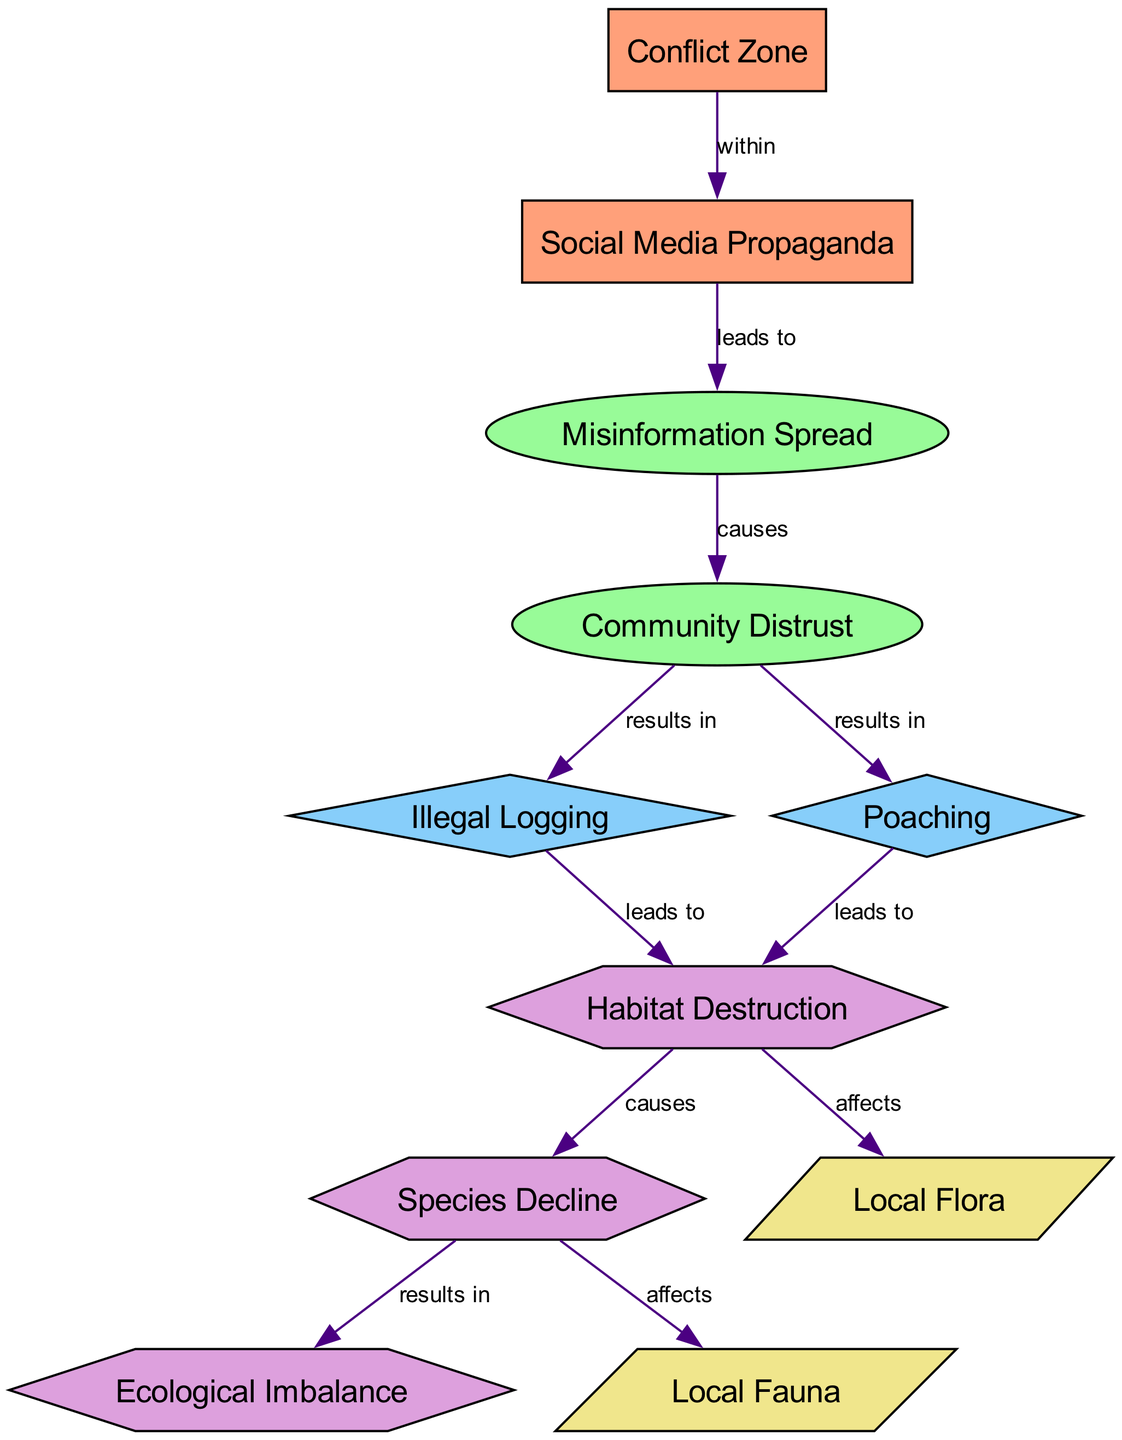What is the total number of nodes in the diagram? The diagram includes 11 different nodes, which are each represented clearly. By counting each node listed, we arrive at the total of 11 nodes.
Answer: 11 How many edges are present in the diagram? The diagram contains 10 edges that connect the various nodes. By examining the edges listed, we can count each connection to find that there are 10 edges.
Answer: 10 What process is caused by misinformation spread? The diagram indicates that misinformation spread causes community distrust as it shows a directed edge from misinformation spread to community distrust.
Answer: Community Distrust What activity results from community distrust? According to the diagram, community distrust results in both illegal logging and poaching, which are connected through directed edges from community distrust.
Answer: Illegal Logging and Poaching Which consequence is directly affected by both habitat destruction and species decline? The diagram shows that both habitat destruction and species decline lead to ecological imbalance as indicated by the edges from these nodes to ecological imbalance.
Answer: Ecological Imbalance What leads to habitat destruction in the context of this diagram? The diagram specifies that both illegal logging and poaching lead to habitat destruction, as indicated by the directed edges from those activities to habitat destruction.
Answer: Illegal Logging and Poaching What is the relationship between social media propaganda and misinformation spread? The diagram denotes that social media propaganda leads to misinformation spread, which is illustrated through a directed edge from social media propaganda to misinformation spread.
Answer: Leads to How do species decline affect local fauna? The diagram states that species decline affects local fauna, as indicated by a directed edge from species decline to local fauna. This signifies a direct impact of species decline on local fauna.
Answer: Affects In which type of environment does social media propaganda occur according to the diagram? The diagram identifies that social media propaganda occurs within a conflict zone, as shown by the directed edge from conflict zone to social media propaganda.
Answer: Conflict Zone What entity is affected by habitat destruction? The diagram shows that local flora is affected by habitat destruction, which is indicated by a directed edge from habitat destruction to local flora.
Answer: Local Flora 